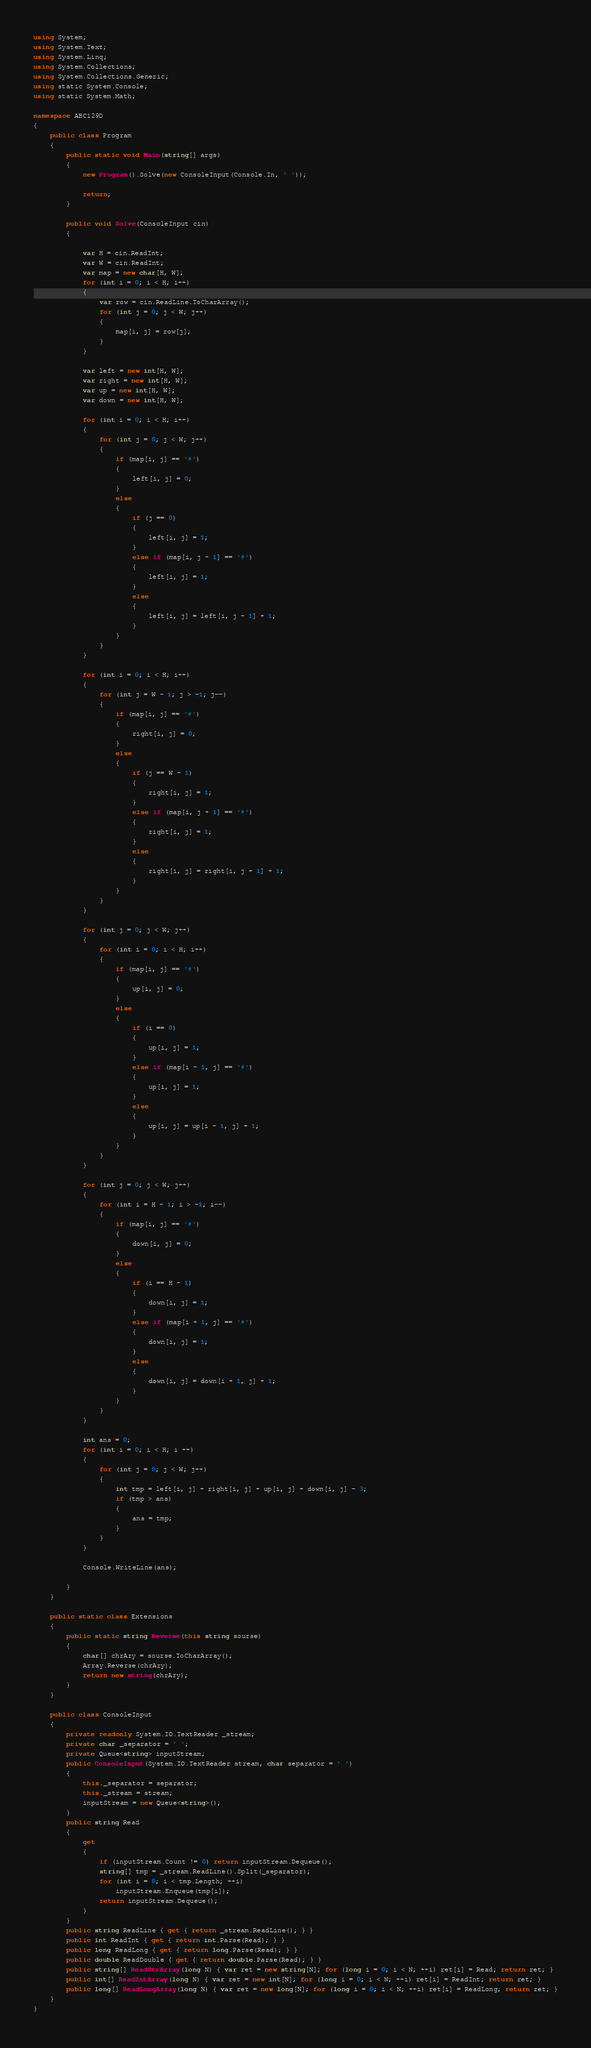<code> <loc_0><loc_0><loc_500><loc_500><_C#_>using System;
using System.Text;
using System.Linq;
using System.Collections;
using System.Collections.Generic;
using static System.Console;
using static System.Math;

namespace ABC129D
{
    public class Program
    {
        public static void Main(string[] args)
        {
            new Program().Solve(new ConsoleInput(Console.In, ' '));

            return;
        }

        public void Solve(ConsoleInput cin)
        {

            var H = cin.ReadInt;
            var W = cin.ReadInt;
            var map = new char[H, W];
            for (int i = 0; i < H; i++)
            {
                var row = cin.ReadLine.ToCharArray();
                for (int j = 0; j < W; j++)
                {
                    map[i, j] = row[j];
                }
            }

            var left = new int[H, W];
            var right = new int[H, W];
            var up = new int[H, W];
            var down = new int[H, W];

            for (int i = 0; i < H; i++)
            {
                for (int j = 0; j < W; j++)
                {
                    if (map[i, j] == '#')
                    {
                        left[i, j] = 0;
                    }
                    else
                    {
                        if (j == 0)
                        {
                            left[i, j] = 1;
                        }
                        else if (map[i, j - 1] == '#')
                        {
                            left[i, j] = 1;
                        }
                        else
                        {
                            left[i, j] = left[i, j - 1] + 1;
                        }
                    }
                }
            }

            for (int i = 0; i < H; i++)
            {
                for (int j = W - 1; j > -1; j--)
                {
                    if (map[i, j] == '#')
                    {
                        right[i, j] = 0;
                    }
                    else
                    {
                        if (j == W - 1)
                        {
                            right[i, j] = 1;
                        }
                        else if (map[i, j + 1] == '#')
                        {
                            right[i, j] = 1;
                        }
                        else
                        {
                            right[i, j] = right[i, j + 1] + 1;
                        }
                    }
                }
            }

            for (int j = 0; j < W; j++)
            {
                for (int i = 0; i < H; i++)
                {
                    if (map[i, j] == '#')
                    {
                        up[i, j] = 0;
                    }
                    else
                    {
                        if (i == 0)
                        {
                            up[i, j] = 1;
                        }
                        else if (map[i - 1, j] == '#')
                        {
                            up[i, j] = 1;
                        }
                        else
                        {
                            up[i, j] = up[i - 1, j] + 1;
                        }
                    }
                }
            }

            for (int j = 0; j < W; j++)
            {
                for (int i = H - 1; i > -1; i--)
                {
                    if (map[i, j] == '#')
                    {
                        down[i, j] = 0;
                    }
                    else
                    {
                        if (i == H - 1)
                        {
                            down[i, j] = 1;
                        }
                        else if (map[i + 1, j] == '#')
                        {
                            down[i, j] = 1;
                        }
                        else
                        {
                            down[i, j] = down[i + 1, j] + 1;
                        }
                    }
                }
            }

            int ans = 0;
            for (int i = 0; i < H; i ++)
            {
                for (int j = 0; j < W; j++)
                {
                    int tmp = left[i, j] + right[i, j] + up[i, j] + down[i, j] - 3;
                    if (tmp > ans)
                    {
                        ans = tmp;
                    }
                }
            }

            Console.WriteLine(ans);

        }
    }

    public static class Extensions
    {
        public static string Reverse(this string sourse)
        {
            char[] chrAry = sourse.ToCharArray();
            Array.Reverse(chrAry);
            return new string(chrAry);
        }
    }

    public class ConsoleInput
    {
        private readonly System.IO.TextReader _stream;
        private char _separator = ' ';
        private Queue<string> inputStream;
        public ConsoleInput(System.IO.TextReader stream, char separator = ' ')
        {
            this._separator = separator;
            this._stream = stream;
            inputStream = new Queue<string>();
        }
        public string Read
        {
            get
            {
                if (inputStream.Count != 0) return inputStream.Dequeue();
                string[] tmp = _stream.ReadLine().Split(_separator);
                for (int i = 0; i < tmp.Length; ++i)
                    inputStream.Enqueue(tmp[i]);
                return inputStream.Dequeue();
            }
        }
        public string ReadLine { get { return _stream.ReadLine(); } }
        public int ReadInt { get { return int.Parse(Read); } }
        public long ReadLong { get { return long.Parse(Read); } }
        public double ReadDouble { get { return double.Parse(Read); } }
        public string[] ReadStrArray(long N) { var ret = new string[N]; for (long i = 0; i < N; ++i) ret[i] = Read; return ret; }
        public int[] ReadIntArray(long N) { var ret = new int[N]; for (long i = 0; i < N; ++i) ret[i] = ReadInt; return ret; }
        public long[] ReadLongArray(long N) { var ret = new long[N]; for (long i = 0; i < N; ++i) ret[i] = ReadLong; return ret; }
    }
}
</code> 